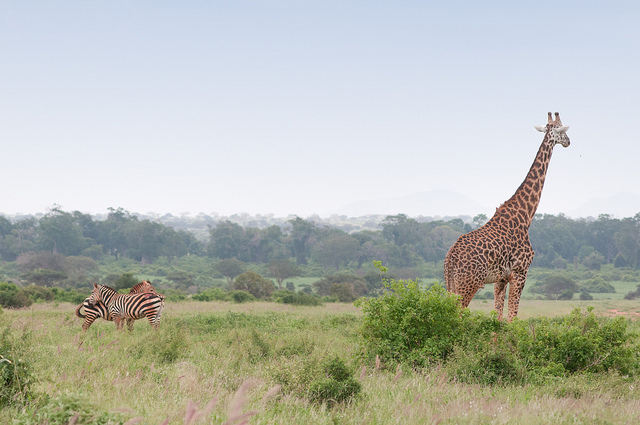<image>Is the giraffe mad at the zebra? I don't know if the giraffe is mad at the zebra. It is not possible to determine the emotions of animals. Is the giraffe mad at the zebra? I don't know if the giraffe is mad at the zebra. It seems like the giraffe is not mad at the zebra. 